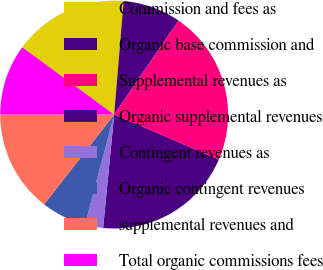Convert chart to OTSL. <chart><loc_0><loc_0><loc_500><loc_500><pie_chart><fcel>Commission and fees as<fcel>Organic base commission and<fcel>Supplemental revenues as<fcel>Organic supplemental revenues<fcel>Contingent revenues as<fcel>Organic contingent revenues<fcel>supplemental revenues and<fcel>Total organic commissions fees<nl><fcel>16.27%<fcel>8.24%<fcel>21.9%<fcel>20.08%<fcel>2.57%<fcel>6.43%<fcel>14.46%<fcel>10.06%<nl></chart> 